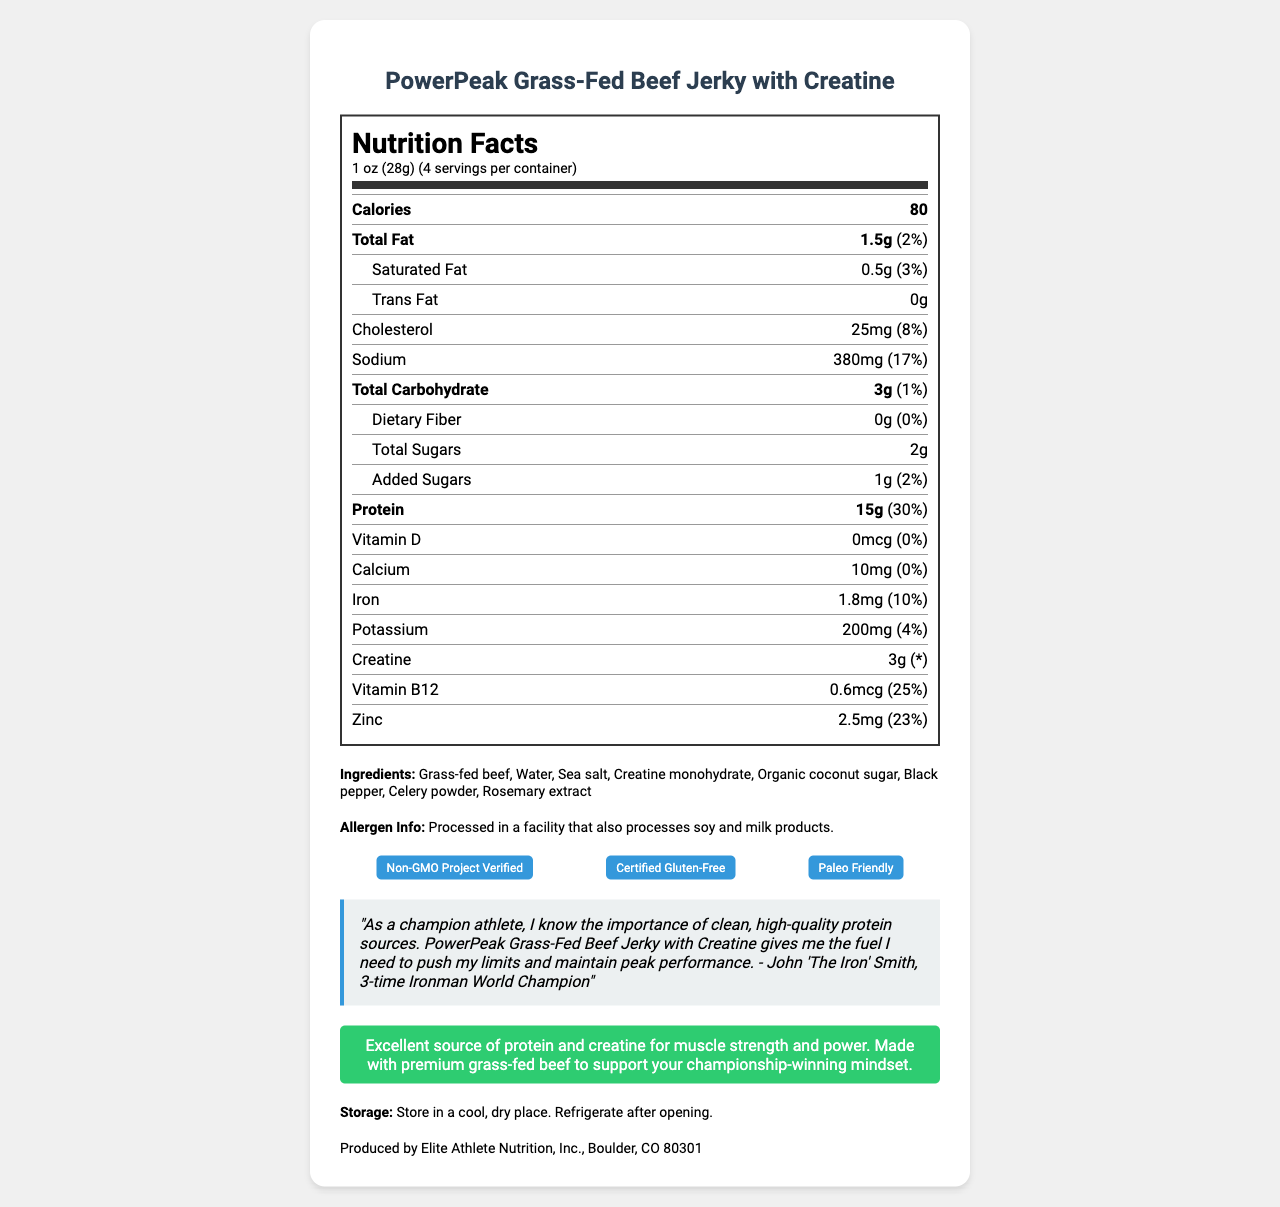how many calories are in one serving? The document states that there are 80 calories in one serving.
Answer: 80 what is the serving size? The serving size listed in the document is 1 oz (28g).
Answer: 1 oz (28g) how many servings are in the container? The document states there are 4 servings per container.
Answer: 4 what is the amount of protein per serving? According to the nutrition facts, there are 15g of protein per serving.
Answer: 15g is the product certified gluten-free? The document mentions that the product is "Certified Gluten-Free" in the certifications section.
Answer: Yes what allergens might be present in this snack? The allergen information states that the product is processed in a facility that also processes soy and milk products.
Answer: Soy and milk products what is the percentage daily value of sodium per serving? A. 3% B. 8% C. 17% D. 30% The nutrition facts indicate that the sodium daily value per serving is 17%.
Answer: C how much creatine is included per serving? The document lists that each serving contains 3g of creatine.
Answer: 3g which vitamin listed has the highest daily value percentage per serving? A. Vitamin D B. Iron C. Vitamin B12 D. Zinc Among the listed options, Vitamin B12 has the highest daily value percentage per serving at 25%.
Answer: C Is the PowerPeak Grass-Fed Beef Jerky with Creatine considered Paleo Friendly? The certifications section of the document includes "Paleo Friendly."
Answer: Yes Who is the athlete that provided a testimonial for this product? The athlete testimonial is given by John 'The Iron' Smith, 3-time Ironman World Champion.
Answer: John 'The Iron' Smith Summarize the main idea of the document. The main sections cover nutrition facts, ingredients, allergens, certifications, a testimonial from a notable athlete, and the claimed benefits of the product, along with storage instructions and manufacturer information.
Answer: The document provides detailed nutrition information for PowerPeak Grass-Fed Beef Jerky with Creatine, highlighting its nutritional values, ingredients, allergens, and certifications. It includes claims about the product’s benefits for muscle strength and performance, supported by a testimonial from a champion athlete. what is the address of the manufacturer? The document does not provide a specific street address, only that the manufacturer is Elite Athlete Nutrition, Inc., located in Boulder, CO 80301.
Answer: Cannot be determined 